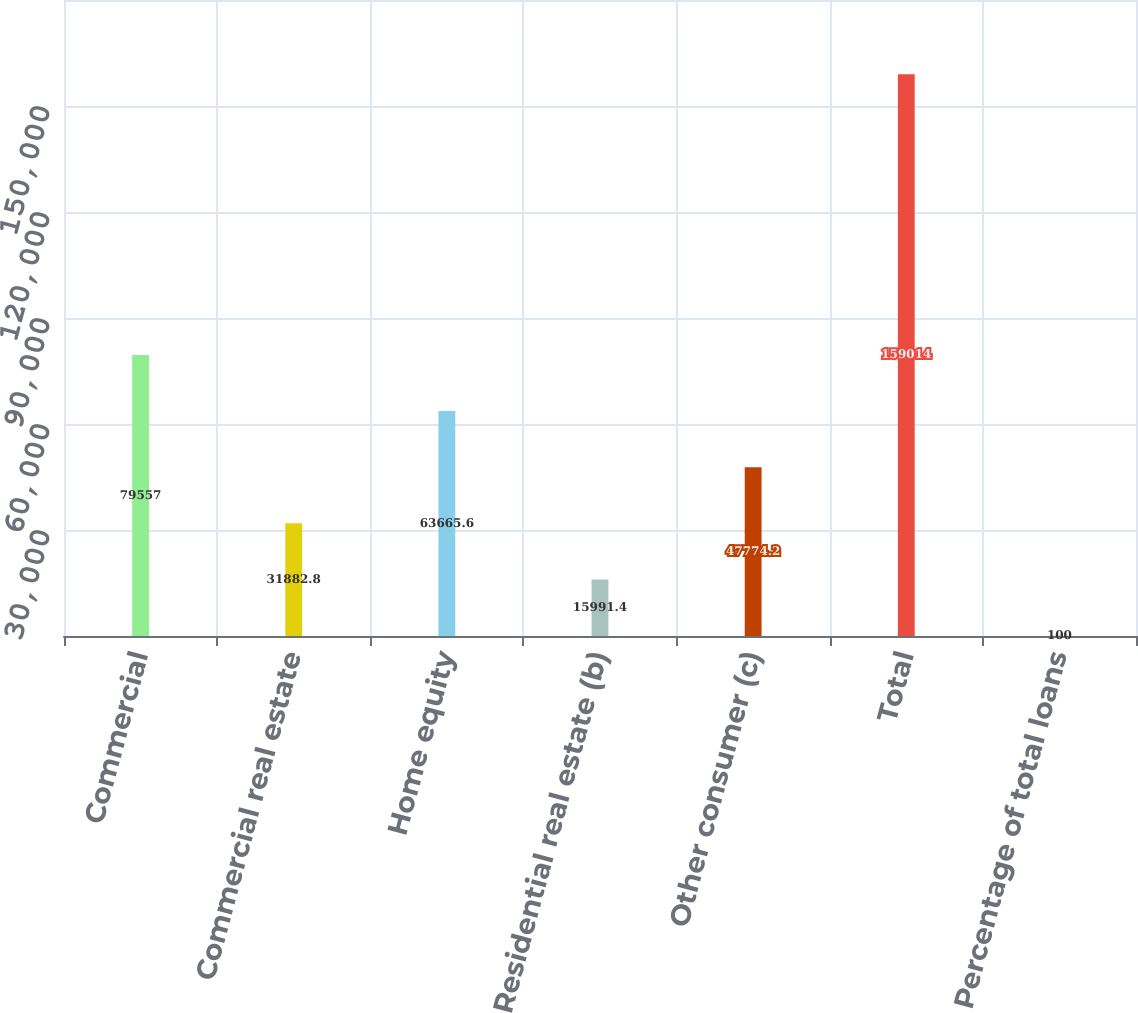Convert chart to OTSL. <chart><loc_0><loc_0><loc_500><loc_500><bar_chart><fcel>Commercial<fcel>Commercial real estate<fcel>Home equity<fcel>Residential real estate (b)<fcel>Other consumer (c)<fcel>Total<fcel>Percentage of total loans<nl><fcel>79557<fcel>31882.8<fcel>63665.6<fcel>15991.4<fcel>47774.2<fcel>159014<fcel>100<nl></chart> 